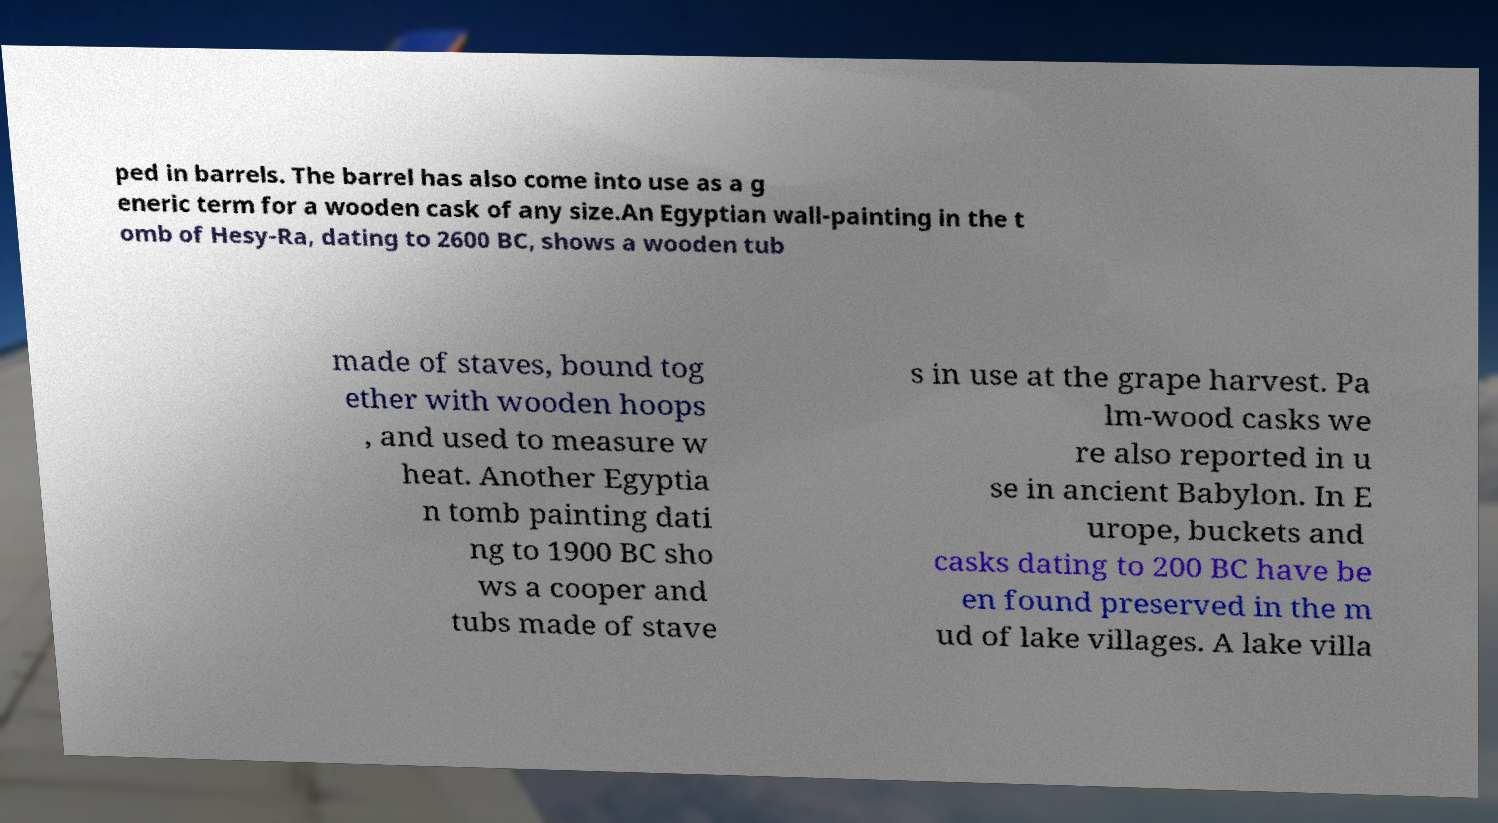What messages or text are displayed in this image? I need them in a readable, typed format. ped in barrels. The barrel has also come into use as a g eneric term for a wooden cask of any size.An Egyptian wall-painting in the t omb of Hesy-Ra, dating to 2600 BC, shows a wooden tub made of staves, bound tog ether with wooden hoops , and used to measure w heat. Another Egyptia n tomb painting dati ng to 1900 BC sho ws a cooper and tubs made of stave s in use at the grape harvest. Pa lm-wood casks we re also reported in u se in ancient Babylon. In E urope, buckets and casks dating to 200 BC have be en found preserved in the m ud of lake villages. A lake villa 